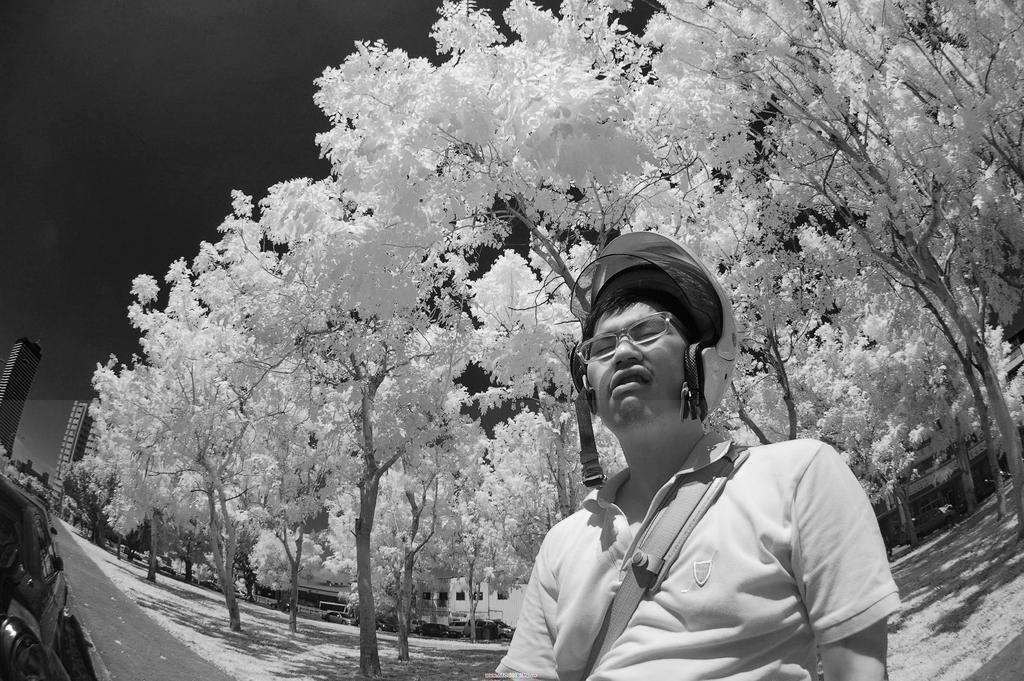In one or two sentences, can you explain what this image depicts? In this image we can see a man is standing, he is wearing the helmet, at the back, here are the trees, here are the buildings, at above here is the sky. 